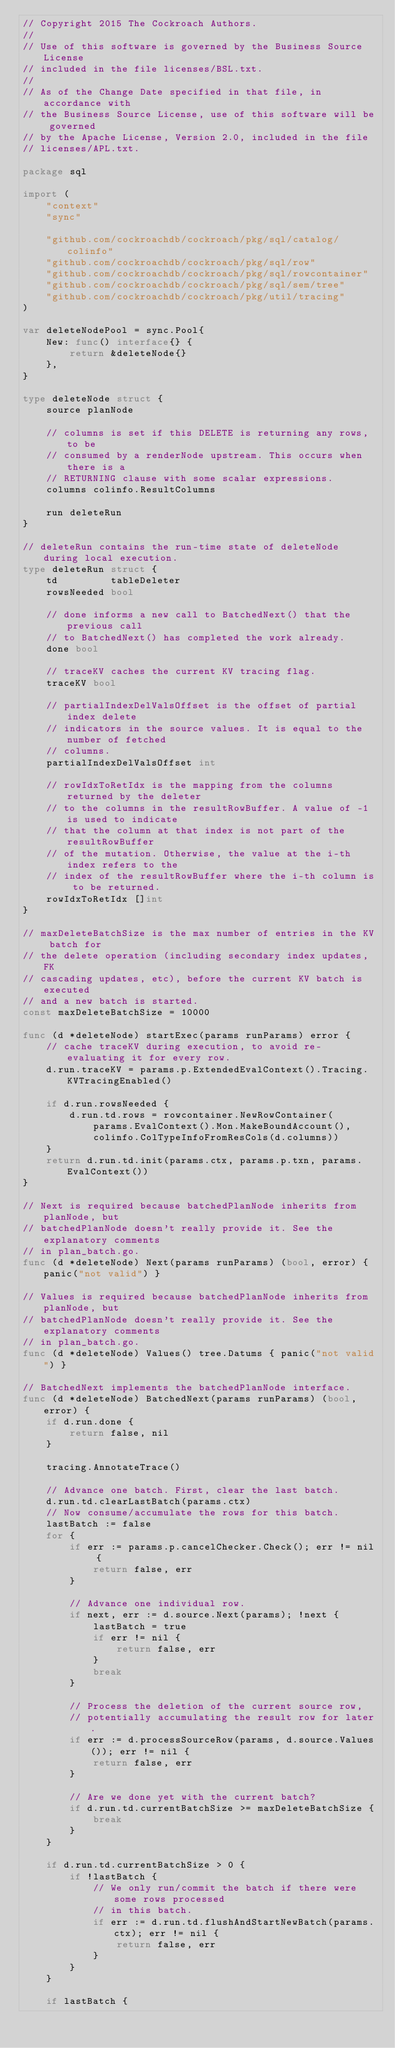Convert code to text. <code><loc_0><loc_0><loc_500><loc_500><_Go_>// Copyright 2015 The Cockroach Authors.
//
// Use of this software is governed by the Business Source License
// included in the file licenses/BSL.txt.
//
// As of the Change Date specified in that file, in accordance with
// the Business Source License, use of this software will be governed
// by the Apache License, Version 2.0, included in the file
// licenses/APL.txt.

package sql

import (
	"context"
	"sync"

	"github.com/cockroachdb/cockroach/pkg/sql/catalog/colinfo"
	"github.com/cockroachdb/cockroach/pkg/sql/row"
	"github.com/cockroachdb/cockroach/pkg/sql/rowcontainer"
	"github.com/cockroachdb/cockroach/pkg/sql/sem/tree"
	"github.com/cockroachdb/cockroach/pkg/util/tracing"
)

var deleteNodePool = sync.Pool{
	New: func() interface{} {
		return &deleteNode{}
	},
}

type deleteNode struct {
	source planNode

	// columns is set if this DELETE is returning any rows, to be
	// consumed by a renderNode upstream. This occurs when there is a
	// RETURNING clause with some scalar expressions.
	columns colinfo.ResultColumns

	run deleteRun
}

// deleteRun contains the run-time state of deleteNode during local execution.
type deleteRun struct {
	td         tableDeleter
	rowsNeeded bool

	// done informs a new call to BatchedNext() that the previous call
	// to BatchedNext() has completed the work already.
	done bool

	// traceKV caches the current KV tracing flag.
	traceKV bool

	// partialIndexDelValsOffset is the offset of partial index delete
	// indicators in the source values. It is equal to the number of fetched
	// columns.
	partialIndexDelValsOffset int

	// rowIdxToRetIdx is the mapping from the columns returned by the deleter
	// to the columns in the resultRowBuffer. A value of -1 is used to indicate
	// that the column at that index is not part of the resultRowBuffer
	// of the mutation. Otherwise, the value at the i-th index refers to the
	// index of the resultRowBuffer where the i-th column is to be returned.
	rowIdxToRetIdx []int
}

// maxDeleteBatchSize is the max number of entries in the KV batch for
// the delete operation (including secondary index updates, FK
// cascading updates, etc), before the current KV batch is executed
// and a new batch is started.
const maxDeleteBatchSize = 10000

func (d *deleteNode) startExec(params runParams) error {
	// cache traceKV during execution, to avoid re-evaluating it for every row.
	d.run.traceKV = params.p.ExtendedEvalContext().Tracing.KVTracingEnabled()

	if d.run.rowsNeeded {
		d.run.td.rows = rowcontainer.NewRowContainer(
			params.EvalContext().Mon.MakeBoundAccount(),
			colinfo.ColTypeInfoFromResCols(d.columns))
	}
	return d.run.td.init(params.ctx, params.p.txn, params.EvalContext())
}

// Next is required because batchedPlanNode inherits from planNode, but
// batchedPlanNode doesn't really provide it. See the explanatory comments
// in plan_batch.go.
func (d *deleteNode) Next(params runParams) (bool, error) { panic("not valid") }

// Values is required because batchedPlanNode inherits from planNode, but
// batchedPlanNode doesn't really provide it. See the explanatory comments
// in plan_batch.go.
func (d *deleteNode) Values() tree.Datums { panic("not valid") }

// BatchedNext implements the batchedPlanNode interface.
func (d *deleteNode) BatchedNext(params runParams) (bool, error) {
	if d.run.done {
		return false, nil
	}

	tracing.AnnotateTrace()

	// Advance one batch. First, clear the last batch.
	d.run.td.clearLastBatch(params.ctx)
	// Now consume/accumulate the rows for this batch.
	lastBatch := false
	for {
		if err := params.p.cancelChecker.Check(); err != nil {
			return false, err
		}

		// Advance one individual row.
		if next, err := d.source.Next(params); !next {
			lastBatch = true
			if err != nil {
				return false, err
			}
			break
		}

		// Process the deletion of the current source row,
		// potentially accumulating the result row for later.
		if err := d.processSourceRow(params, d.source.Values()); err != nil {
			return false, err
		}

		// Are we done yet with the current batch?
		if d.run.td.currentBatchSize >= maxDeleteBatchSize {
			break
		}
	}

	if d.run.td.currentBatchSize > 0 {
		if !lastBatch {
			// We only run/commit the batch if there were some rows processed
			// in this batch.
			if err := d.run.td.flushAndStartNewBatch(params.ctx); err != nil {
				return false, err
			}
		}
	}

	if lastBatch {</code> 